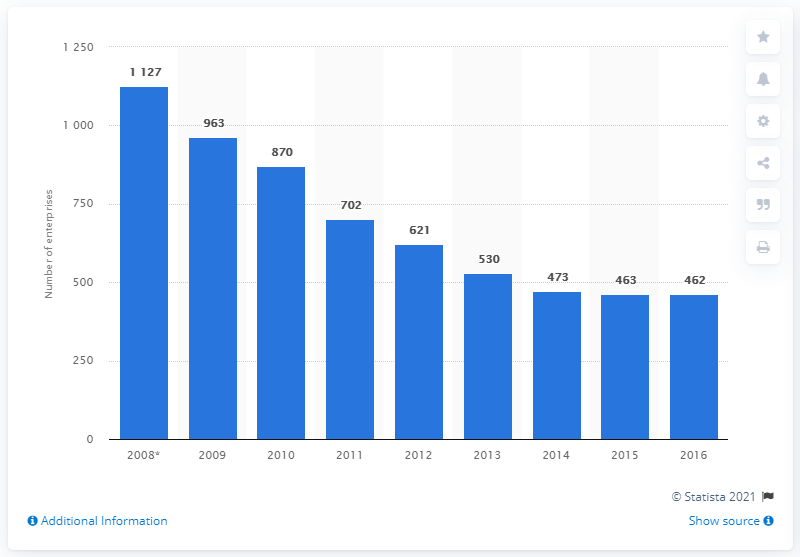Draw attention to some important aspects in this diagram. In 2016, 462 enterprises in Italy were engaged in the manufacture of computers and related equipment. 